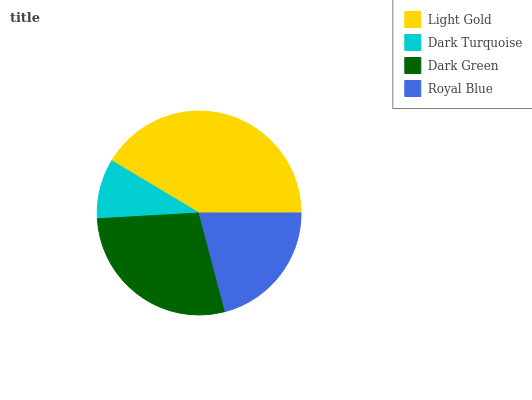Is Dark Turquoise the minimum?
Answer yes or no. Yes. Is Light Gold the maximum?
Answer yes or no. Yes. Is Dark Green the minimum?
Answer yes or no. No. Is Dark Green the maximum?
Answer yes or no. No. Is Dark Green greater than Dark Turquoise?
Answer yes or no. Yes. Is Dark Turquoise less than Dark Green?
Answer yes or no. Yes. Is Dark Turquoise greater than Dark Green?
Answer yes or no. No. Is Dark Green less than Dark Turquoise?
Answer yes or no. No. Is Dark Green the high median?
Answer yes or no. Yes. Is Royal Blue the low median?
Answer yes or no. Yes. Is Royal Blue the high median?
Answer yes or no. No. Is Light Gold the low median?
Answer yes or no. No. 